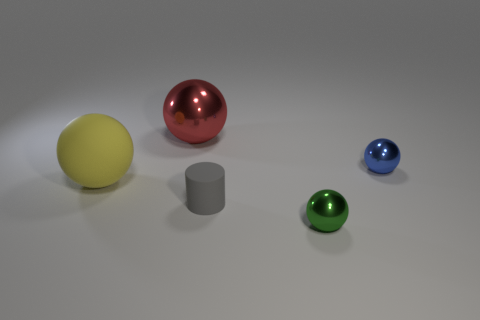What materials do the objects in the image seem to be made of? The objects in the image appear to be made of different materials. The large yellow ball seems to be rubbery, the small grey cylinder has a matte finish suggesting a metallic or plastic material, while the small red, blue, and green balls look shiny, possibly indicating a metallic or glass-like material. 